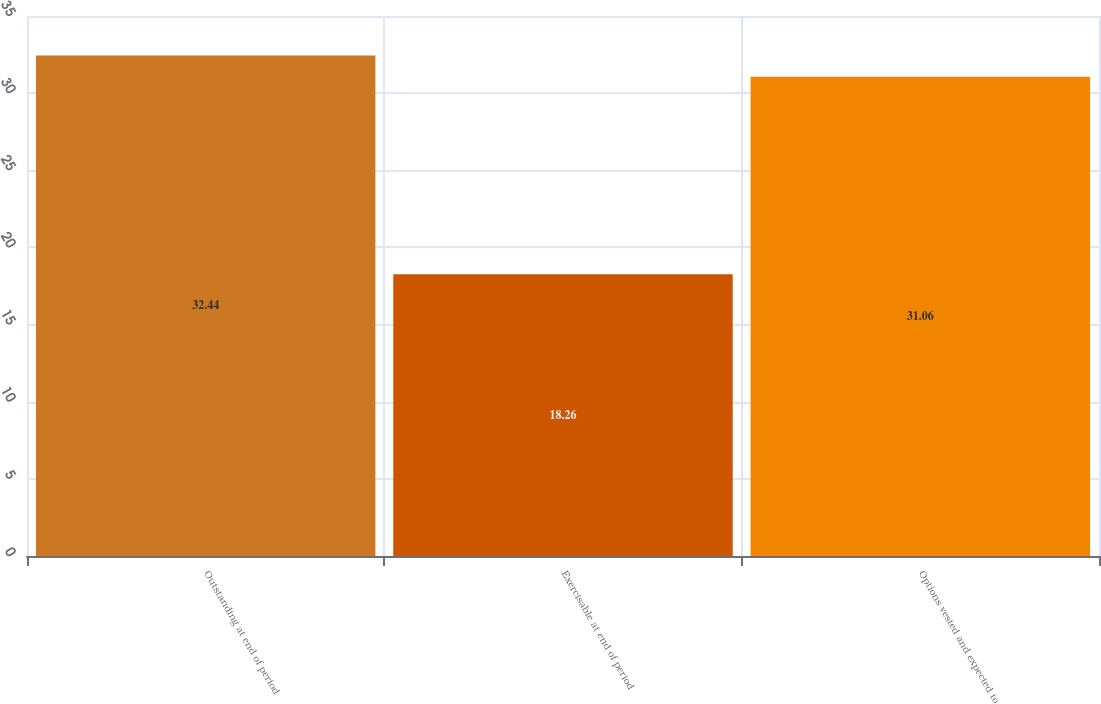<chart> <loc_0><loc_0><loc_500><loc_500><bar_chart><fcel>Outstanding at end of period<fcel>Exercisable at end of period<fcel>Options vested and expected to<nl><fcel>32.44<fcel>18.26<fcel>31.06<nl></chart> 